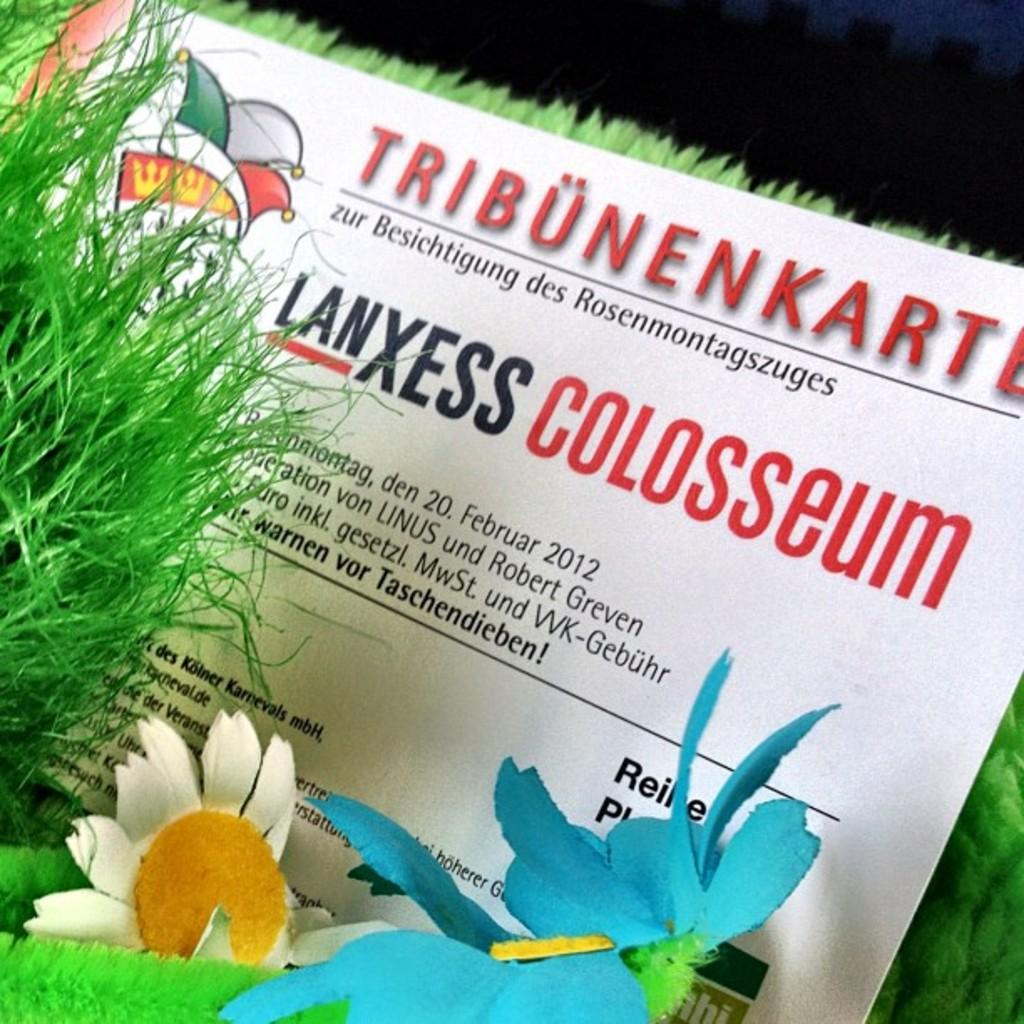What type of flowers are present in the image? There are artificial flowers in the image. What type of ground cover is present in the image? There is artificial grass in the image. What is written on the banner in the image? The banner in the image has text and numbers. What type of ring can be seen on the donkey's nose in the image? There is no donkey or ring present in the image; it only features artificial flowers, grass, and a banner. 